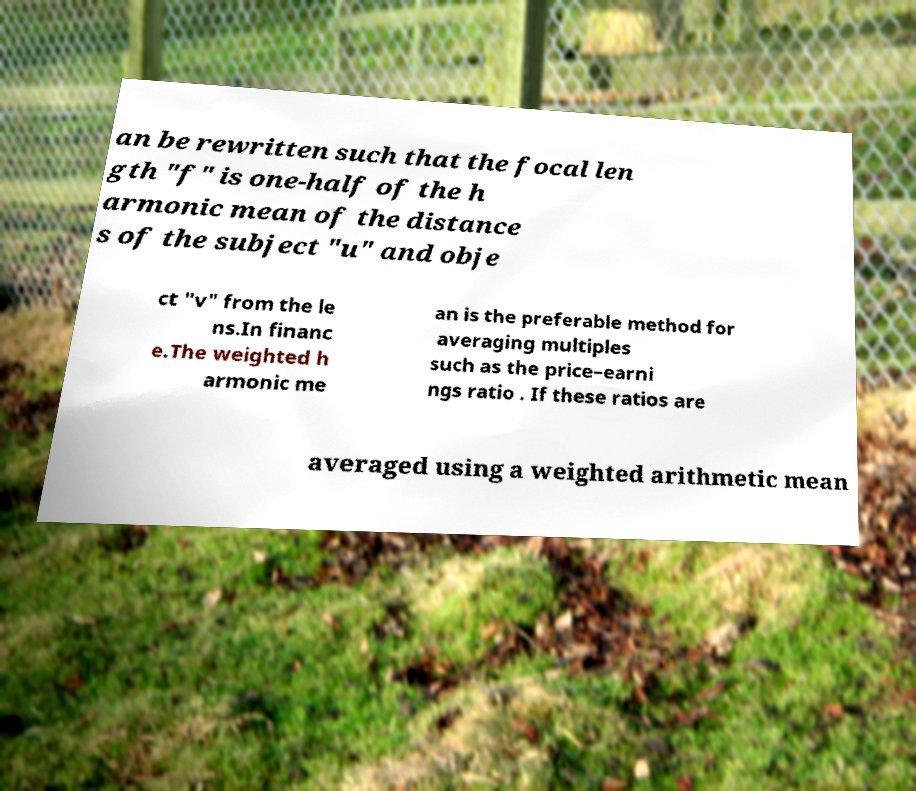Could you assist in decoding the text presented in this image and type it out clearly? an be rewritten such that the focal len gth "f" is one-half of the h armonic mean of the distance s of the subject "u" and obje ct "v" from the le ns.In financ e.The weighted h armonic me an is the preferable method for averaging multiples such as the price–earni ngs ratio . If these ratios are averaged using a weighted arithmetic mean 